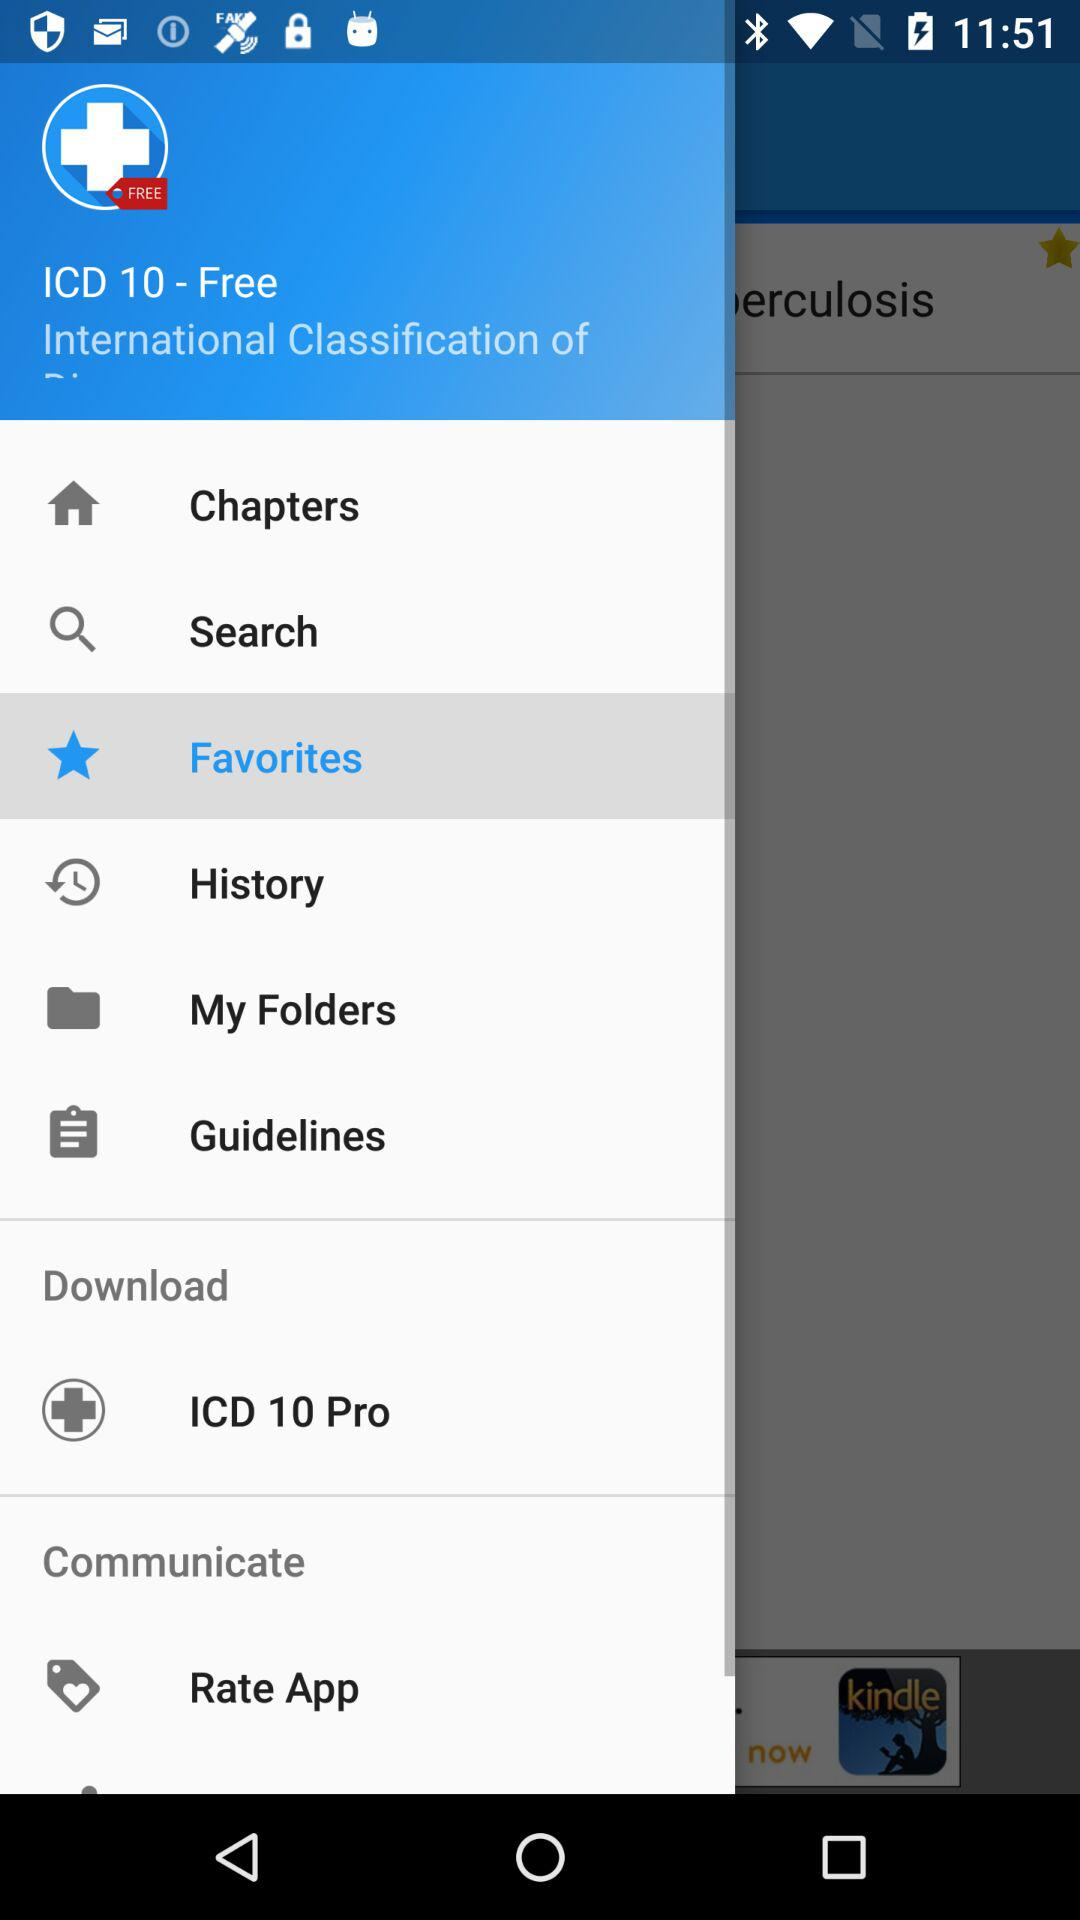Which option is selected? The selected option is "Favorites". 